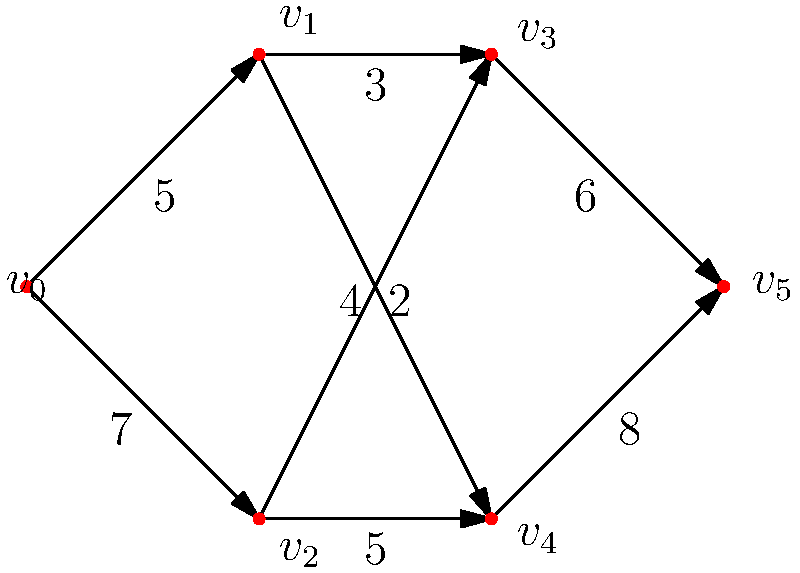As a patent office supervisor, you are tasked with optimizing the workload distribution among patent examiners. The network flow diagram represents the capacity of different examiners to handle various types of patent applications. Vertex $v_0$ represents the source (incoming applications), and vertex $v_5$ represents the sink (completed examinations). The edges represent the maximum number of applications that can be processed along each path per week. What is the maximum flow of patent applications that can be processed through this network per week? To find the maximum flow in this network, we can use the Ford-Fulkerson algorithm:

1. Start with zero flow on all edges.

2. Find an augmenting path from source to sink:
   Path 1: $v_0 \rightarrow v_1 \rightarrow v_3 \rightarrow v_5$ (min capacity = 3)
   Increase flow by 3.

3. Find another augmenting path:
   Path 2: $v_0 \rightarrow v_2 \rightarrow v_4 \rightarrow v_5$ (min capacity = 5)
   Increase flow by 5.

4. Find another augmenting path:
   Path 3: $v_0 \rightarrow v_1 \rightarrow v_4 \rightarrow v_5$ (min capacity = 2)
   Increase flow by 2.

5. Find another augmenting path:
   Path 4: $v_0 \rightarrow v_2 \rightarrow v_3 \rightarrow v_5$ (min capacity = 2)
   Increase flow by 2.

6. No more augmenting paths exist.

7. Sum up the flows:
   Total maximum flow = 3 + 5 + 2 + 2 = 12

Therefore, the maximum flow of patent applications that can be processed through this network per week is 12.
Answer: 12 applications per week 